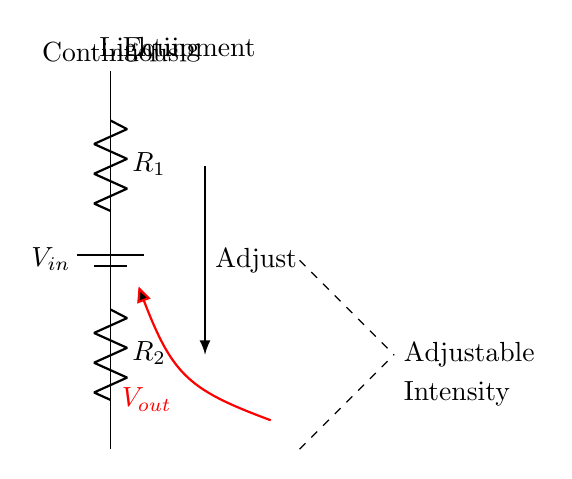What is the input voltage in this circuit? The input voltage is labeled as V_in at the top of the circuit diagram, indicating the voltage supplied to the circuit.
Answer: V_in What components are present in the circuit? The diagram contains a battery (indicating a power supply), two resistors (R_1 and R_2), and a light bulb symbol (representing the continuous lighting equipment).
Answer: Battery, Resistors, Light bulb What is the purpose of the output voltage V_out? V_out represents the adjustable voltage supply that controls the intensity of the attached lighting equipment based on the voltage division between the two resistors.
Answer: Adjustable voltage Which component's resistance primarily controls the output voltage? The resistance of R_1 has a significant role in determining the output voltage along with R_2 based on the voltage divider rule, making it an important controlling factor.
Answer: R_1 How does adjusting the resistors affect light intensity? By changing the resistance values of R_1 or R_2, the output voltage V_out changes, leading to a corresponding adjustment in the brightness of the light bulb. The voltage divider principle shows the relationship between resistance and output voltage.
Answer: Changes brightness Where does the output voltage connect in the circuit? The output voltage connects from the node between resistors R_1 and R_2 to the light bulb, indicating it feeds power to the light source for intensity adjustment.
Answer: To the light bulb 